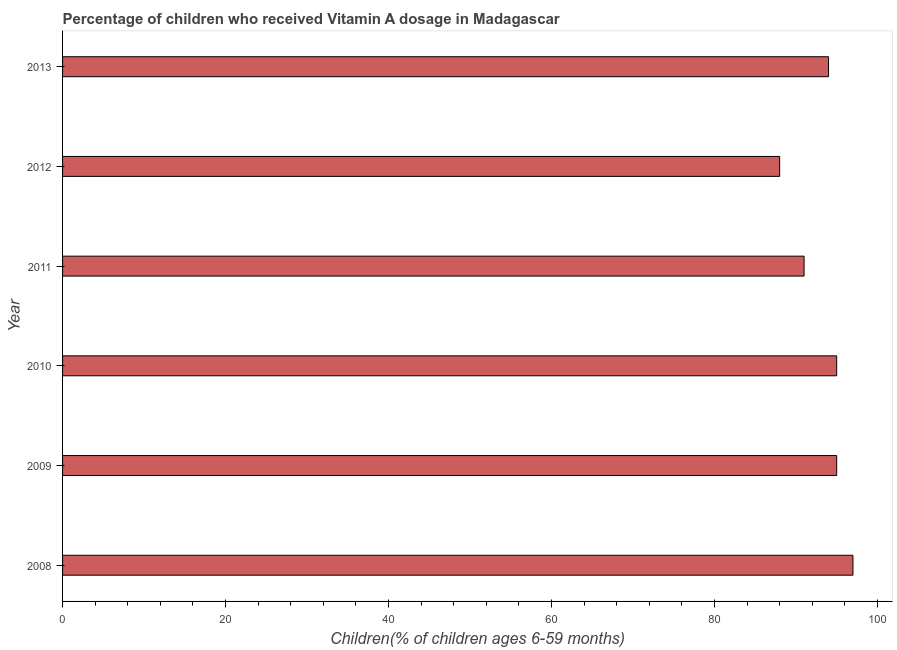Does the graph contain any zero values?
Provide a succinct answer. No. Does the graph contain grids?
Keep it short and to the point. No. What is the title of the graph?
Ensure brevity in your answer.  Percentage of children who received Vitamin A dosage in Madagascar. What is the label or title of the X-axis?
Keep it short and to the point. Children(% of children ages 6-59 months). What is the vitamin a supplementation coverage rate in 2008?
Your answer should be very brief. 97. Across all years, what is the maximum vitamin a supplementation coverage rate?
Provide a succinct answer. 97. Across all years, what is the minimum vitamin a supplementation coverage rate?
Your response must be concise. 88. What is the sum of the vitamin a supplementation coverage rate?
Keep it short and to the point. 560. What is the average vitamin a supplementation coverage rate per year?
Offer a very short reply. 93. What is the median vitamin a supplementation coverage rate?
Provide a succinct answer. 94.5. In how many years, is the vitamin a supplementation coverage rate greater than 36 %?
Give a very brief answer. 6. Do a majority of the years between 2011 and 2012 (inclusive) have vitamin a supplementation coverage rate greater than 92 %?
Give a very brief answer. No. What is the ratio of the vitamin a supplementation coverage rate in 2012 to that in 2013?
Provide a short and direct response. 0.94. Is the vitamin a supplementation coverage rate in 2012 less than that in 2013?
Your response must be concise. Yes. Is the difference between the vitamin a supplementation coverage rate in 2010 and 2011 greater than the difference between any two years?
Your answer should be very brief. No. Is the sum of the vitamin a supplementation coverage rate in 2010 and 2011 greater than the maximum vitamin a supplementation coverage rate across all years?
Keep it short and to the point. Yes. What is the difference between two consecutive major ticks on the X-axis?
Ensure brevity in your answer.  20. What is the Children(% of children ages 6-59 months) in 2008?
Offer a terse response. 97. What is the Children(% of children ages 6-59 months) in 2010?
Offer a very short reply. 95. What is the Children(% of children ages 6-59 months) in 2011?
Offer a terse response. 91. What is the Children(% of children ages 6-59 months) of 2013?
Give a very brief answer. 94. What is the difference between the Children(% of children ages 6-59 months) in 2008 and 2010?
Make the answer very short. 2. What is the difference between the Children(% of children ages 6-59 months) in 2008 and 2011?
Provide a short and direct response. 6. What is the difference between the Children(% of children ages 6-59 months) in 2009 and 2011?
Your answer should be very brief. 4. What is the difference between the Children(% of children ages 6-59 months) in 2009 and 2012?
Offer a very short reply. 7. What is the difference between the Children(% of children ages 6-59 months) in 2010 and 2013?
Provide a succinct answer. 1. What is the difference between the Children(% of children ages 6-59 months) in 2011 and 2012?
Your response must be concise. 3. What is the ratio of the Children(% of children ages 6-59 months) in 2008 to that in 2011?
Provide a short and direct response. 1.07. What is the ratio of the Children(% of children ages 6-59 months) in 2008 to that in 2012?
Offer a very short reply. 1.1. What is the ratio of the Children(% of children ages 6-59 months) in 2008 to that in 2013?
Your answer should be very brief. 1.03. What is the ratio of the Children(% of children ages 6-59 months) in 2009 to that in 2010?
Your answer should be compact. 1. What is the ratio of the Children(% of children ages 6-59 months) in 2009 to that in 2011?
Provide a short and direct response. 1.04. What is the ratio of the Children(% of children ages 6-59 months) in 2009 to that in 2012?
Keep it short and to the point. 1.08. What is the ratio of the Children(% of children ages 6-59 months) in 2009 to that in 2013?
Keep it short and to the point. 1.01. What is the ratio of the Children(% of children ages 6-59 months) in 2010 to that in 2011?
Keep it short and to the point. 1.04. What is the ratio of the Children(% of children ages 6-59 months) in 2010 to that in 2012?
Ensure brevity in your answer.  1.08. What is the ratio of the Children(% of children ages 6-59 months) in 2011 to that in 2012?
Provide a succinct answer. 1.03. What is the ratio of the Children(% of children ages 6-59 months) in 2012 to that in 2013?
Offer a terse response. 0.94. 